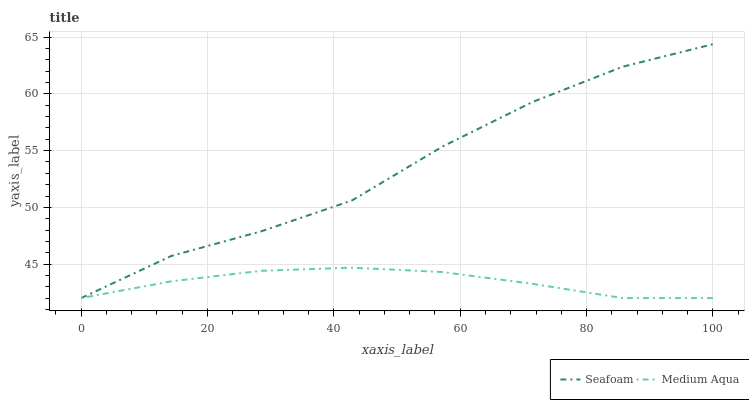Does Seafoam have the minimum area under the curve?
Answer yes or no. No. Is Seafoam the smoothest?
Answer yes or no. No. 